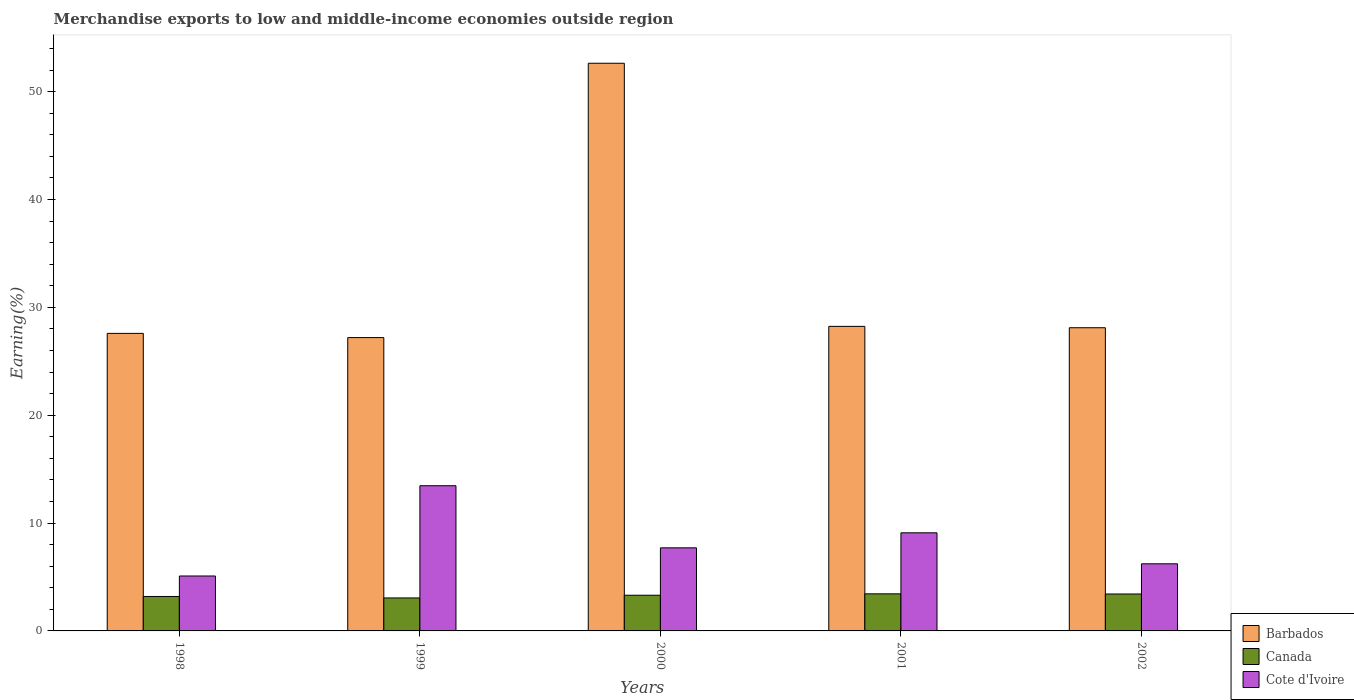How many groups of bars are there?
Your answer should be very brief. 5. Are the number of bars per tick equal to the number of legend labels?
Your answer should be very brief. Yes. Are the number of bars on each tick of the X-axis equal?
Your response must be concise. Yes. How many bars are there on the 1st tick from the right?
Your answer should be compact. 3. What is the label of the 4th group of bars from the left?
Ensure brevity in your answer.  2001. In how many cases, is the number of bars for a given year not equal to the number of legend labels?
Ensure brevity in your answer.  0. What is the percentage of amount earned from merchandise exports in Cote d'Ivoire in 2001?
Provide a short and direct response. 9.1. Across all years, what is the maximum percentage of amount earned from merchandise exports in Barbados?
Your answer should be compact. 52.63. Across all years, what is the minimum percentage of amount earned from merchandise exports in Canada?
Offer a terse response. 3.06. What is the total percentage of amount earned from merchandise exports in Barbados in the graph?
Keep it short and to the point. 163.75. What is the difference between the percentage of amount earned from merchandise exports in Barbados in 2001 and that in 2002?
Your answer should be very brief. 0.13. What is the difference between the percentage of amount earned from merchandise exports in Cote d'Ivoire in 1998 and the percentage of amount earned from merchandise exports in Canada in 1999?
Make the answer very short. 2.04. What is the average percentage of amount earned from merchandise exports in Canada per year?
Your answer should be compact. 3.28. In the year 2002, what is the difference between the percentage of amount earned from merchandise exports in Barbados and percentage of amount earned from merchandise exports in Cote d'Ivoire?
Keep it short and to the point. 21.89. What is the ratio of the percentage of amount earned from merchandise exports in Canada in 2001 to that in 2002?
Provide a succinct answer. 1. Is the percentage of amount earned from merchandise exports in Canada in 2000 less than that in 2002?
Provide a succinct answer. Yes. What is the difference between the highest and the second highest percentage of amount earned from merchandise exports in Cote d'Ivoire?
Give a very brief answer. 4.36. What is the difference between the highest and the lowest percentage of amount earned from merchandise exports in Barbados?
Offer a very short reply. 25.43. Is the sum of the percentage of amount earned from merchandise exports in Cote d'Ivoire in 2000 and 2002 greater than the maximum percentage of amount earned from merchandise exports in Barbados across all years?
Offer a very short reply. No. What does the 2nd bar from the left in 2001 represents?
Offer a terse response. Canada. What does the 1st bar from the right in 2001 represents?
Provide a short and direct response. Cote d'Ivoire. Does the graph contain any zero values?
Provide a short and direct response. No. Does the graph contain grids?
Give a very brief answer. No. What is the title of the graph?
Offer a terse response. Merchandise exports to low and middle-income economies outside region. What is the label or title of the X-axis?
Give a very brief answer. Years. What is the label or title of the Y-axis?
Your answer should be compact. Earning(%). What is the Earning(%) of Barbados in 1998?
Make the answer very short. 27.58. What is the Earning(%) of Canada in 1998?
Offer a terse response. 3.19. What is the Earning(%) of Cote d'Ivoire in 1998?
Give a very brief answer. 5.09. What is the Earning(%) in Barbados in 1999?
Give a very brief answer. 27.19. What is the Earning(%) of Canada in 1999?
Make the answer very short. 3.06. What is the Earning(%) of Cote d'Ivoire in 1999?
Provide a short and direct response. 13.46. What is the Earning(%) of Barbados in 2000?
Offer a very short reply. 52.63. What is the Earning(%) in Canada in 2000?
Your answer should be very brief. 3.31. What is the Earning(%) of Cote d'Ivoire in 2000?
Provide a short and direct response. 7.7. What is the Earning(%) of Barbados in 2001?
Your response must be concise. 28.23. What is the Earning(%) in Canada in 2001?
Offer a very short reply. 3.44. What is the Earning(%) in Cote d'Ivoire in 2001?
Provide a succinct answer. 9.1. What is the Earning(%) in Barbados in 2002?
Your answer should be very brief. 28.11. What is the Earning(%) in Canada in 2002?
Offer a very short reply. 3.42. What is the Earning(%) in Cote d'Ivoire in 2002?
Provide a succinct answer. 6.22. Across all years, what is the maximum Earning(%) of Barbados?
Your response must be concise. 52.63. Across all years, what is the maximum Earning(%) of Canada?
Your answer should be compact. 3.44. Across all years, what is the maximum Earning(%) in Cote d'Ivoire?
Make the answer very short. 13.46. Across all years, what is the minimum Earning(%) in Barbados?
Make the answer very short. 27.19. Across all years, what is the minimum Earning(%) of Canada?
Offer a very short reply. 3.06. Across all years, what is the minimum Earning(%) of Cote d'Ivoire?
Your response must be concise. 5.09. What is the total Earning(%) of Barbados in the graph?
Offer a terse response. 163.75. What is the total Earning(%) in Canada in the graph?
Keep it short and to the point. 16.42. What is the total Earning(%) in Cote d'Ivoire in the graph?
Your answer should be very brief. 41.57. What is the difference between the Earning(%) of Barbados in 1998 and that in 1999?
Give a very brief answer. 0.39. What is the difference between the Earning(%) of Canada in 1998 and that in 1999?
Keep it short and to the point. 0.14. What is the difference between the Earning(%) of Cote d'Ivoire in 1998 and that in 1999?
Offer a terse response. -8.37. What is the difference between the Earning(%) in Barbados in 1998 and that in 2000?
Your answer should be very brief. -25.04. What is the difference between the Earning(%) in Canada in 1998 and that in 2000?
Offer a very short reply. -0.12. What is the difference between the Earning(%) of Cote d'Ivoire in 1998 and that in 2000?
Offer a terse response. -2.61. What is the difference between the Earning(%) in Barbados in 1998 and that in 2001?
Ensure brevity in your answer.  -0.65. What is the difference between the Earning(%) of Canada in 1998 and that in 2001?
Ensure brevity in your answer.  -0.25. What is the difference between the Earning(%) in Cote d'Ivoire in 1998 and that in 2001?
Make the answer very short. -4. What is the difference between the Earning(%) of Barbados in 1998 and that in 2002?
Offer a terse response. -0.52. What is the difference between the Earning(%) in Canada in 1998 and that in 2002?
Your response must be concise. -0.23. What is the difference between the Earning(%) in Cote d'Ivoire in 1998 and that in 2002?
Give a very brief answer. -1.13. What is the difference between the Earning(%) of Barbados in 1999 and that in 2000?
Provide a succinct answer. -25.43. What is the difference between the Earning(%) of Canada in 1999 and that in 2000?
Give a very brief answer. -0.25. What is the difference between the Earning(%) in Cote d'Ivoire in 1999 and that in 2000?
Your answer should be compact. 5.76. What is the difference between the Earning(%) in Barbados in 1999 and that in 2001?
Offer a terse response. -1.04. What is the difference between the Earning(%) in Canada in 1999 and that in 2001?
Provide a succinct answer. -0.38. What is the difference between the Earning(%) in Cote d'Ivoire in 1999 and that in 2001?
Offer a very short reply. 4.36. What is the difference between the Earning(%) of Barbados in 1999 and that in 2002?
Give a very brief answer. -0.91. What is the difference between the Earning(%) of Canada in 1999 and that in 2002?
Your response must be concise. -0.37. What is the difference between the Earning(%) in Cote d'Ivoire in 1999 and that in 2002?
Your answer should be compact. 7.24. What is the difference between the Earning(%) of Barbados in 2000 and that in 2001?
Keep it short and to the point. 24.39. What is the difference between the Earning(%) in Canada in 2000 and that in 2001?
Your answer should be compact. -0.13. What is the difference between the Earning(%) of Cote d'Ivoire in 2000 and that in 2001?
Your answer should be compact. -1.39. What is the difference between the Earning(%) of Barbados in 2000 and that in 2002?
Make the answer very short. 24.52. What is the difference between the Earning(%) of Canada in 2000 and that in 2002?
Provide a succinct answer. -0.12. What is the difference between the Earning(%) in Cote d'Ivoire in 2000 and that in 2002?
Provide a succinct answer. 1.48. What is the difference between the Earning(%) of Barbados in 2001 and that in 2002?
Offer a very short reply. 0.13. What is the difference between the Earning(%) in Canada in 2001 and that in 2002?
Provide a succinct answer. 0.01. What is the difference between the Earning(%) of Cote d'Ivoire in 2001 and that in 2002?
Give a very brief answer. 2.87. What is the difference between the Earning(%) of Barbados in 1998 and the Earning(%) of Canada in 1999?
Provide a succinct answer. 24.53. What is the difference between the Earning(%) in Barbados in 1998 and the Earning(%) in Cote d'Ivoire in 1999?
Offer a terse response. 14.12. What is the difference between the Earning(%) of Canada in 1998 and the Earning(%) of Cote d'Ivoire in 1999?
Provide a succinct answer. -10.27. What is the difference between the Earning(%) in Barbados in 1998 and the Earning(%) in Canada in 2000?
Your answer should be very brief. 24.28. What is the difference between the Earning(%) in Barbados in 1998 and the Earning(%) in Cote d'Ivoire in 2000?
Provide a succinct answer. 19.88. What is the difference between the Earning(%) in Canada in 1998 and the Earning(%) in Cote d'Ivoire in 2000?
Your answer should be compact. -4.51. What is the difference between the Earning(%) of Barbados in 1998 and the Earning(%) of Canada in 2001?
Offer a very short reply. 24.14. What is the difference between the Earning(%) of Barbados in 1998 and the Earning(%) of Cote d'Ivoire in 2001?
Keep it short and to the point. 18.49. What is the difference between the Earning(%) of Canada in 1998 and the Earning(%) of Cote d'Ivoire in 2001?
Your answer should be compact. -5.9. What is the difference between the Earning(%) of Barbados in 1998 and the Earning(%) of Canada in 2002?
Your answer should be very brief. 24.16. What is the difference between the Earning(%) of Barbados in 1998 and the Earning(%) of Cote d'Ivoire in 2002?
Your response must be concise. 21.36. What is the difference between the Earning(%) of Canada in 1998 and the Earning(%) of Cote d'Ivoire in 2002?
Offer a very short reply. -3.03. What is the difference between the Earning(%) in Barbados in 1999 and the Earning(%) in Canada in 2000?
Ensure brevity in your answer.  23.89. What is the difference between the Earning(%) of Barbados in 1999 and the Earning(%) of Cote d'Ivoire in 2000?
Your answer should be very brief. 19.49. What is the difference between the Earning(%) of Canada in 1999 and the Earning(%) of Cote d'Ivoire in 2000?
Offer a terse response. -4.65. What is the difference between the Earning(%) of Barbados in 1999 and the Earning(%) of Canada in 2001?
Your response must be concise. 23.76. What is the difference between the Earning(%) of Barbados in 1999 and the Earning(%) of Cote d'Ivoire in 2001?
Provide a succinct answer. 18.1. What is the difference between the Earning(%) in Canada in 1999 and the Earning(%) in Cote d'Ivoire in 2001?
Make the answer very short. -6.04. What is the difference between the Earning(%) in Barbados in 1999 and the Earning(%) in Canada in 2002?
Provide a short and direct response. 23.77. What is the difference between the Earning(%) of Barbados in 1999 and the Earning(%) of Cote d'Ivoire in 2002?
Offer a very short reply. 20.97. What is the difference between the Earning(%) of Canada in 1999 and the Earning(%) of Cote d'Ivoire in 2002?
Your answer should be compact. -3.17. What is the difference between the Earning(%) of Barbados in 2000 and the Earning(%) of Canada in 2001?
Your answer should be very brief. 49.19. What is the difference between the Earning(%) of Barbados in 2000 and the Earning(%) of Cote d'Ivoire in 2001?
Provide a short and direct response. 43.53. What is the difference between the Earning(%) of Canada in 2000 and the Earning(%) of Cote d'Ivoire in 2001?
Offer a terse response. -5.79. What is the difference between the Earning(%) of Barbados in 2000 and the Earning(%) of Canada in 2002?
Your answer should be compact. 49.2. What is the difference between the Earning(%) in Barbados in 2000 and the Earning(%) in Cote d'Ivoire in 2002?
Your answer should be compact. 46.4. What is the difference between the Earning(%) of Canada in 2000 and the Earning(%) of Cote d'Ivoire in 2002?
Give a very brief answer. -2.91. What is the difference between the Earning(%) in Barbados in 2001 and the Earning(%) in Canada in 2002?
Provide a succinct answer. 24.81. What is the difference between the Earning(%) in Barbados in 2001 and the Earning(%) in Cote d'Ivoire in 2002?
Offer a terse response. 22.01. What is the difference between the Earning(%) of Canada in 2001 and the Earning(%) of Cote d'Ivoire in 2002?
Provide a succinct answer. -2.78. What is the average Earning(%) in Barbados per year?
Provide a short and direct response. 32.75. What is the average Earning(%) in Canada per year?
Offer a terse response. 3.28. What is the average Earning(%) of Cote d'Ivoire per year?
Your answer should be very brief. 8.31. In the year 1998, what is the difference between the Earning(%) of Barbados and Earning(%) of Canada?
Your response must be concise. 24.39. In the year 1998, what is the difference between the Earning(%) of Barbados and Earning(%) of Cote d'Ivoire?
Offer a very short reply. 22.49. In the year 1998, what is the difference between the Earning(%) of Canada and Earning(%) of Cote d'Ivoire?
Make the answer very short. -1.9. In the year 1999, what is the difference between the Earning(%) of Barbados and Earning(%) of Canada?
Offer a terse response. 24.14. In the year 1999, what is the difference between the Earning(%) in Barbados and Earning(%) in Cote d'Ivoire?
Offer a terse response. 13.73. In the year 1999, what is the difference between the Earning(%) of Canada and Earning(%) of Cote d'Ivoire?
Keep it short and to the point. -10.4. In the year 2000, what is the difference between the Earning(%) in Barbados and Earning(%) in Canada?
Offer a very short reply. 49.32. In the year 2000, what is the difference between the Earning(%) of Barbados and Earning(%) of Cote d'Ivoire?
Your answer should be very brief. 44.92. In the year 2000, what is the difference between the Earning(%) of Canada and Earning(%) of Cote d'Ivoire?
Your answer should be compact. -4.39. In the year 2001, what is the difference between the Earning(%) in Barbados and Earning(%) in Canada?
Offer a very short reply. 24.8. In the year 2001, what is the difference between the Earning(%) in Barbados and Earning(%) in Cote d'Ivoire?
Make the answer very short. 19.14. In the year 2001, what is the difference between the Earning(%) in Canada and Earning(%) in Cote d'Ivoire?
Your answer should be compact. -5.66. In the year 2002, what is the difference between the Earning(%) in Barbados and Earning(%) in Canada?
Your answer should be compact. 24.68. In the year 2002, what is the difference between the Earning(%) of Barbados and Earning(%) of Cote d'Ivoire?
Your answer should be very brief. 21.89. In the year 2002, what is the difference between the Earning(%) of Canada and Earning(%) of Cote d'Ivoire?
Make the answer very short. -2.8. What is the ratio of the Earning(%) in Barbados in 1998 to that in 1999?
Ensure brevity in your answer.  1.01. What is the ratio of the Earning(%) in Canada in 1998 to that in 1999?
Give a very brief answer. 1.04. What is the ratio of the Earning(%) in Cote d'Ivoire in 1998 to that in 1999?
Provide a short and direct response. 0.38. What is the ratio of the Earning(%) of Barbados in 1998 to that in 2000?
Offer a terse response. 0.52. What is the ratio of the Earning(%) of Canada in 1998 to that in 2000?
Offer a terse response. 0.97. What is the ratio of the Earning(%) in Cote d'Ivoire in 1998 to that in 2000?
Your response must be concise. 0.66. What is the ratio of the Earning(%) of Barbados in 1998 to that in 2001?
Offer a very short reply. 0.98. What is the ratio of the Earning(%) in Cote d'Ivoire in 1998 to that in 2001?
Your answer should be very brief. 0.56. What is the ratio of the Earning(%) of Barbados in 1998 to that in 2002?
Give a very brief answer. 0.98. What is the ratio of the Earning(%) in Canada in 1998 to that in 2002?
Offer a very short reply. 0.93. What is the ratio of the Earning(%) of Cote d'Ivoire in 1998 to that in 2002?
Your response must be concise. 0.82. What is the ratio of the Earning(%) of Barbados in 1999 to that in 2000?
Your answer should be very brief. 0.52. What is the ratio of the Earning(%) in Canada in 1999 to that in 2000?
Keep it short and to the point. 0.92. What is the ratio of the Earning(%) in Cote d'Ivoire in 1999 to that in 2000?
Give a very brief answer. 1.75. What is the ratio of the Earning(%) in Barbados in 1999 to that in 2001?
Your response must be concise. 0.96. What is the ratio of the Earning(%) in Canada in 1999 to that in 2001?
Your answer should be very brief. 0.89. What is the ratio of the Earning(%) of Cote d'Ivoire in 1999 to that in 2001?
Your answer should be very brief. 1.48. What is the ratio of the Earning(%) of Barbados in 1999 to that in 2002?
Offer a terse response. 0.97. What is the ratio of the Earning(%) of Canada in 1999 to that in 2002?
Ensure brevity in your answer.  0.89. What is the ratio of the Earning(%) in Cote d'Ivoire in 1999 to that in 2002?
Give a very brief answer. 2.16. What is the ratio of the Earning(%) in Barbados in 2000 to that in 2001?
Provide a short and direct response. 1.86. What is the ratio of the Earning(%) of Canada in 2000 to that in 2001?
Provide a succinct answer. 0.96. What is the ratio of the Earning(%) of Cote d'Ivoire in 2000 to that in 2001?
Make the answer very short. 0.85. What is the ratio of the Earning(%) of Barbados in 2000 to that in 2002?
Make the answer very short. 1.87. What is the ratio of the Earning(%) of Canada in 2000 to that in 2002?
Your answer should be compact. 0.97. What is the ratio of the Earning(%) of Cote d'Ivoire in 2000 to that in 2002?
Your response must be concise. 1.24. What is the ratio of the Earning(%) in Cote d'Ivoire in 2001 to that in 2002?
Your answer should be compact. 1.46. What is the difference between the highest and the second highest Earning(%) of Barbados?
Provide a short and direct response. 24.39. What is the difference between the highest and the second highest Earning(%) in Canada?
Offer a very short reply. 0.01. What is the difference between the highest and the second highest Earning(%) in Cote d'Ivoire?
Offer a terse response. 4.36. What is the difference between the highest and the lowest Earning(%) in Barbados?
Ensure brevity in your answer.  25.43. What is the difference between the highest and the lowest Earning(%) in Canada?
Offer a very short reply. 0.38. What is the difference between the highest and the lowest Earning(%) of Cote d'Ivoire?
Offer a very short reply. 8.37. 